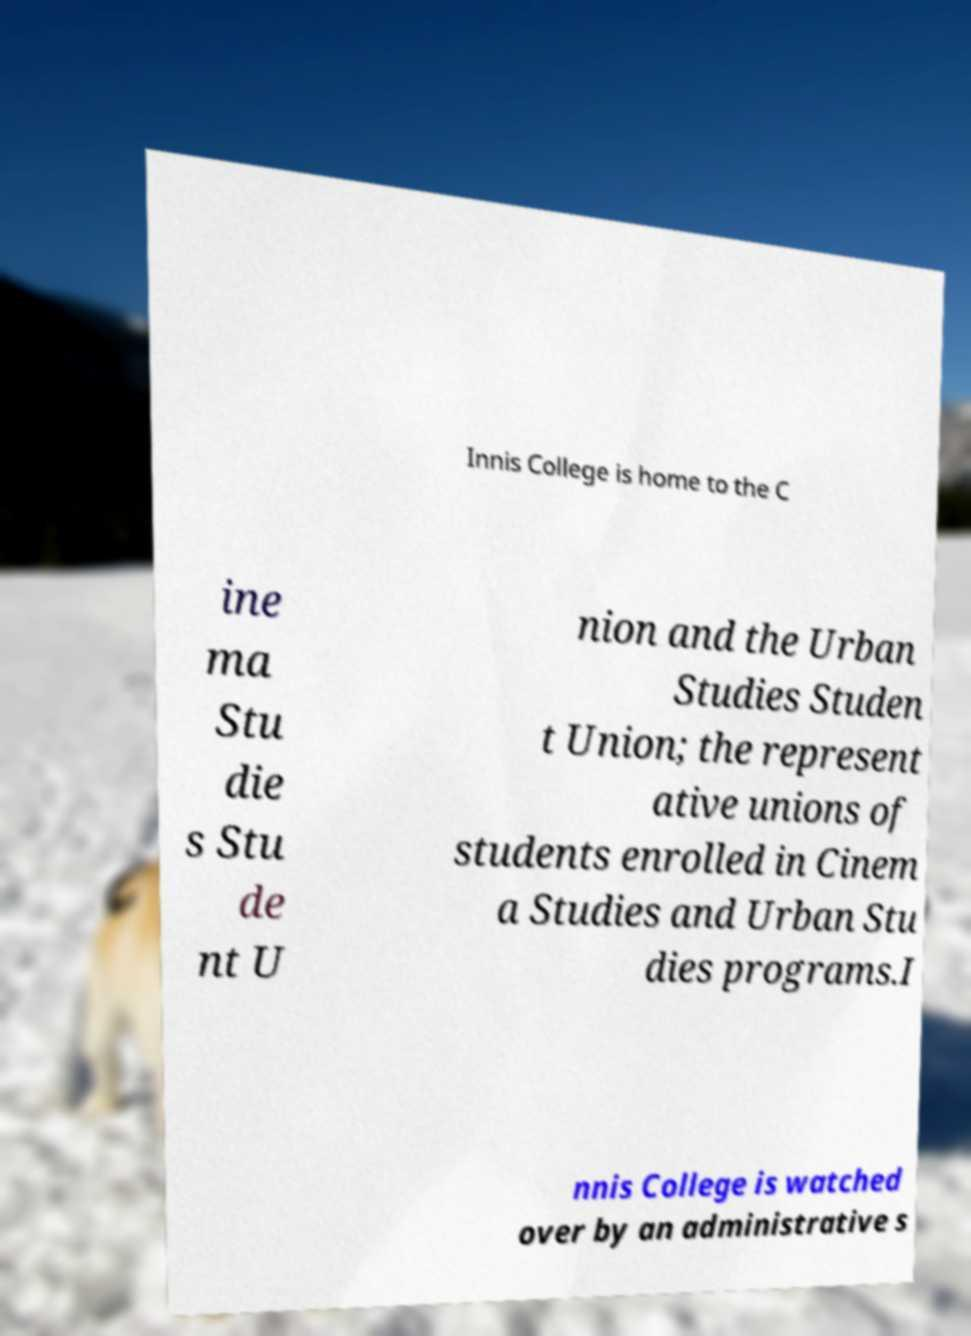I need the written content from this picture converted into text. Can you do that? Innis College is home to the C ine ma Stu die s Stu de nt U nion and the Urban Studies Studen t Union; the represent ative unions of students enrolled in Cinem a Studies and Urban Stu dies programs.I nnis College is watched over by an administrative s 